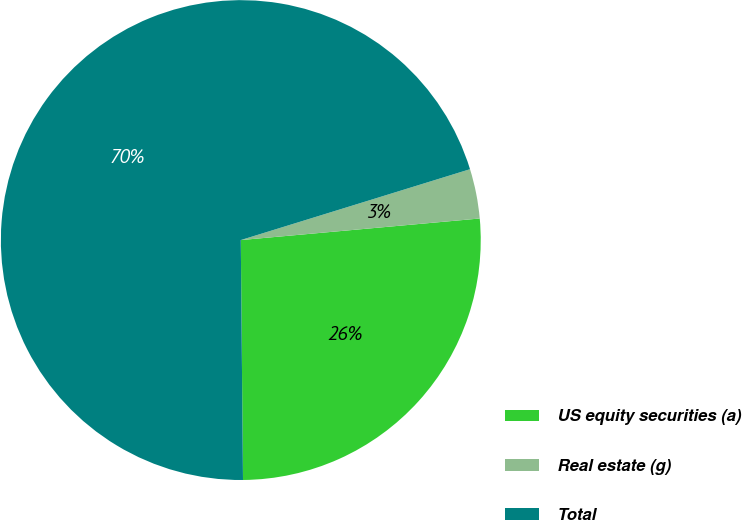Convert chart to OTSL. <chart><loc_0><loc_0><loc_500><loc_500><pie_chart><fcel>US equity securities (a)<fcel>Real estate (g)<fcel>Total<nl><fcel>26.29%<fcel>3.34%<fcel>70.38%<nl></chart> 